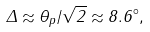<formula> <loc_0><loc_0><loc_500><loc_500>\Delta \approx \theta _ { p } / \sqrt { 2 } \approx 8 . 6 ^ { \circ } ,</formula> 